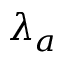<formula> <loc_0><loc_0><loc_500><loc_500>\lambda _ { a }</formula> 